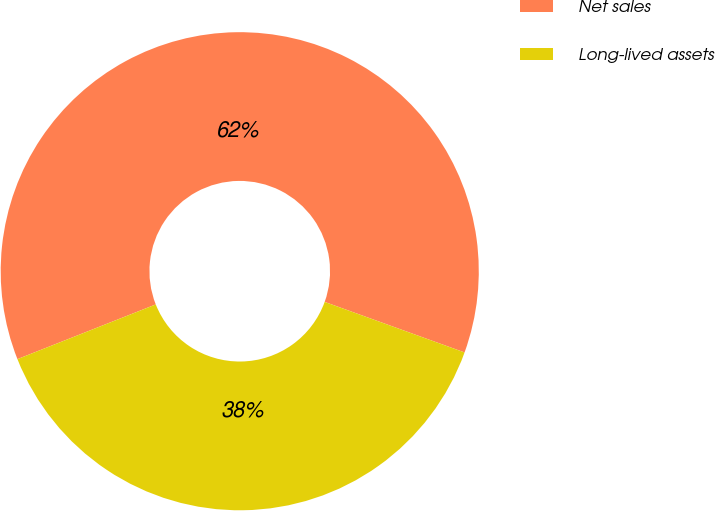<chart> <loc_0><loc_0><loc_500><loc_500><pie_chart><fcel>Net sales<fcel>Long-lived assets<nl><fcel>61.51%<fcel>38.49%<nl></chart> 